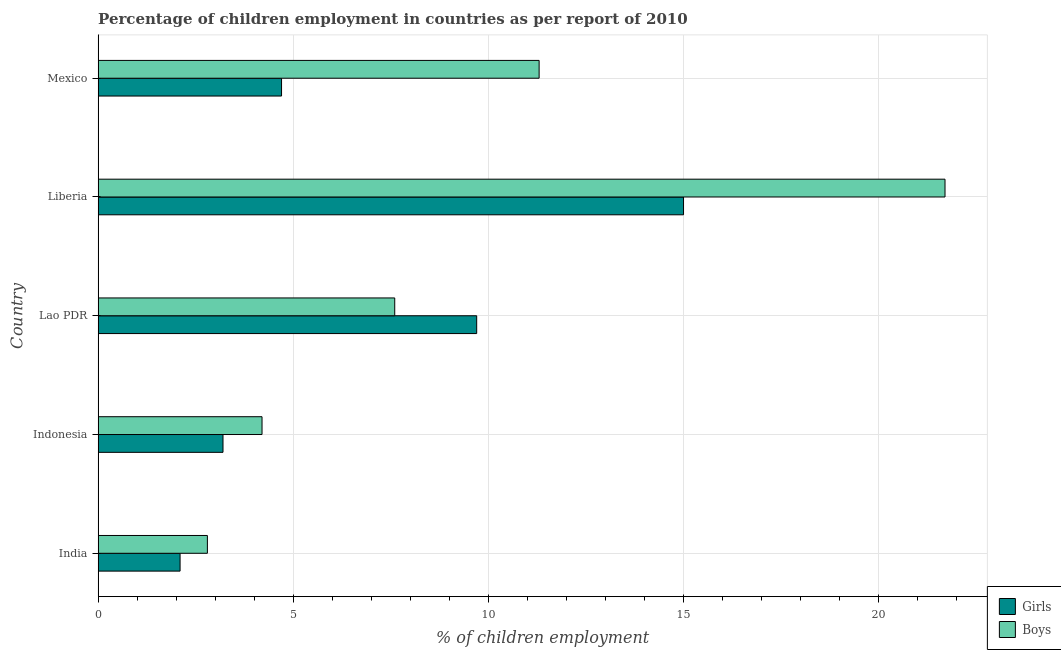How many groups of bars are there?
Your response must be concise. 5. What is the label of the 2nd group of bars from the top?
Offer a terse response. Liberia. In how many cases, is the number of bars for a given country not equal to the number of legend labels?
Offer a terse response. 0. Across all countries, what is the maximum percentage of employed boys?
Offer a terse response. 21.7. In which country was the percentage of employed boys maximum?
Give a very brief answer. Liberia. In which country was the percentage of employed girls minimum?
Give a very brief answer. India. What is the total percentage of employed boys in the graph?
Your answer should be compact. 47.6. What is the difference between the percentage of employed boys in Lao PDR and that in Mexico?
Provide a short and direct response. -3.7. What is the difference between the percentage of employed girls in Mexico and the percentage of employed boys in India?
Make the answer very short. 1.9. What is the average percentage of employed boys per country?
Your answer should be compact. 9.52. What is the difference between the percentage of employed boys and percentage of employed girls in Liberia?
Your response must be concise. 6.7. In how many countries, is the percentage of employed girls greater than 3 %?
Keep it short and to the point. 4. What is the ratio of the percentage of employed girls in Indonesia to that in Liberia?
Your answer should be compact. 0.21. What is the difference between the highest and the lowest percentage of employed girls?
Offer a terse response. 12.9. What does the 2nd bar from the top in India represents?
Make the answer very short. Girls. What does the 2nd bar from the bottom in Lao PDR represents?
Provide a short and direct response. Boys. Are all the bars in the graph horizontal?
Give a very brief answer. Yes. What is the difference between two consecutive major ticks on the X-axis?
Keep it short and to the point. 5. Does the graph contain grids?
Ensure brevity in your answer.  Yes. What is the title of the graph?
Your answer should be compact. Percentage of children employment in countries as per report of 2010. What is the label or title of the X-axis?
Your response must be concise. % of children employment. What is the label or title of the Y-axis?
Give a very brief answer. Country. What is the % of children employment in Girls in India?
Keep it short and to the point. 2.1. What is the % of children employment of Boys in India?
Offer a very short reply. 2.8. What is the % of children employment of Girls in Indonesia?
Offer a very short reply. 3.2. What is the % of children employment in Girls in Lao PDR?
Make the answer very short. 9.7. What is the % of children employment in Boys in Liberia?
Provide a succinct answer. 21.7. Across all countries, what is the maximum % of children employment in Girls?
Offer a terse response. 15. Across all countries, what is the maximum % of children employment in Boys?
Your answer should be compact. 21.7. Across all countries, what is the minimum % of children employment of Girls?
Give a very brief answer. 2.1. Across all countries, what is the minimum % of children employment of Boys?
Provide a succinct answer. 2.8. What is the total % of children employment in Girls in the graph?
Your answer should be compact. 34.7. What is the total % of children employment in Boys in the graph?
Keep it short and to the point. 47.6. What is the difference between the % of children employment in Girls in India and that in Liberia?
Your answer should be very brief. -12.9. What is the difference between the % of children employment of Boys in India and that in Liberia?
Make the answer very short. -18.9. What is the difference between the % of children employment of Girls in India and that in Mexico?
Keep it short and to the point. -2.6. What is the difference between the % of children employment in Girls in Indonesia and that in Lao PDR?
Your answer should be very brief. -6.5. What is the difference between the % of children employment of Boys in Indonesia and that in Liberia?
Provide a short and direct response. -17.5. What is the difference between the % of children employment of Boys in Indonesia and that in Mexico?
Make the answer very short. -7.1. What is the difference between the % of children employment of Boys in Lao PDR and that in Liberia?
Give a very brief answer. -14.1. What is the difference between the % of children employment in Girls in Lao PDR and that in Mexico?
Offer a very short reply. 5. What is the difference between the % of children employment in Boys in Liberia and that in Mexico?
Provide a succinct answer. 10.4. What is the difference between the % of children employment of Girls in India and the % of children employment of Boys in Indonesia?
Ensure brevity in your answer.  -2.1. What is the difference between the % of children employment in Girls in India and the % of children employment in Boys in Lao PDR?
Offer a terse response. -5.5. What is the difference between the % of children employment of Girls in India and the % of children employment of Boys in Liberia?
Your response must be concise. -19.6. What is the difference between the % of children employment of Girls in India and the % of children employment of Boys in Mexico?
Provide a succinct answer. -9.2. What is the difference between the % of children employment in Girls in Indonesia and the % of children employment in Boys in Liberia?
Your response must be concise. -18.5. What is the difference between the % of children employment in Girls in Indonesia and the % of children employment in Boys in Mexico?
Provide a short and direct response. -8.1. What is the difference between the % of children employment in Girls in Lao PDR and the % of children employment in Boys in Mexico?
Give a very brief answer. -1.6. What is the average % of children employment in Girls per country?
Your answer should be very brief. 6.94. What is the average % of children employment in Boys per country?
Provide a succinct answer. 9.52. What is the difference between the % of children employment of Girls and % of children employment of Boys in India?
Provide a short and direct response. -0.7. What is the difference between the % of children employment in Girls and % of children employment in Boys in Lao PDR?
Your answer should be compact. 2.1. What is the ratio of the % of children employment of Girls in India to that in Indonesia?
Offer a terse response. 0.66. What is the ratio of the % of children employment in Girls in India to that in Lao PDR?
Provide a succinct answer. 0.22. What is the ratio of the % of children employment in Boys in India to that in Lao PDR?
Offer a very short reply. 0.37. What is the ratio of the % of children employment in Girls in India to that in Liberia?
Your answer should be very brief. 0.14. What is the ratio of the % of children employment in Boys in India to that in Liberia?
Ensure brevity in your answer.  0.13. What is the ratio of the % of children employment in Girls in India to that in Mexico?
Keep it short and to the point. 0.45. What is the ratio of the % of children employment in Boys in India to that in Mexico?
Provide a short and direct response. 0.25. What is the ratio of the % of children employment of Girls in Indonesia to that in Lao PDR?
Make the answer very short. 0.33. What is the ratio of the % of children employment of Boys in Indonesia to that in Lao PDR?
Your answer should be compact. 0.55. What is the ratio of the % of children employment in Girls in Indonesia to that in Liberia?
Provide a short and direct response. 0.21. What is the ratio of the % of children employment of Boys in Indonesia to that in Liberia?
Keep it short and to the point. 0.19. What is the ratio of the % of children employment in Girls in Indonesia to that in Mexico?
Keep it short and to the point. 0.68. What is the ratio of the % of children employment in Boys in Indonesia to that in Mexico?
Ensure brevity in your answer.  0.37. What is the ratio of the % of children employment in Girls in Lao PDR to that in Liberia?
Your answer should be compact. 0.65. What is the ratio of the % of children employment of Boys in Lao PDR to that in Liberia?
Offer a very short reply. 0.35. What is the ratio of the % of children employment in Girls in Lao PDR to that in Mexico?
Your answer should be very brief. 2.06. What is the ratio of the % of children employment of Boys in Lao PDR to that in Mexico?
Provide a succinct answer. 0.67. What is the ratio of the % of children employment of Girls in Liberia to that in Mexico?
Offer a terse response. 3.19. What is the ratio of the % of children employment in Boys in Liberia to that in Mexico?
Make the answer very short. 1.92. What is the difference between the highest and the second highest % of children employment of Boys?
Provide a short and direct response. 10.4. What is the difference between the highest and the lowest % of children employment in Girls?
Your answer should be very brief. 12.9. 